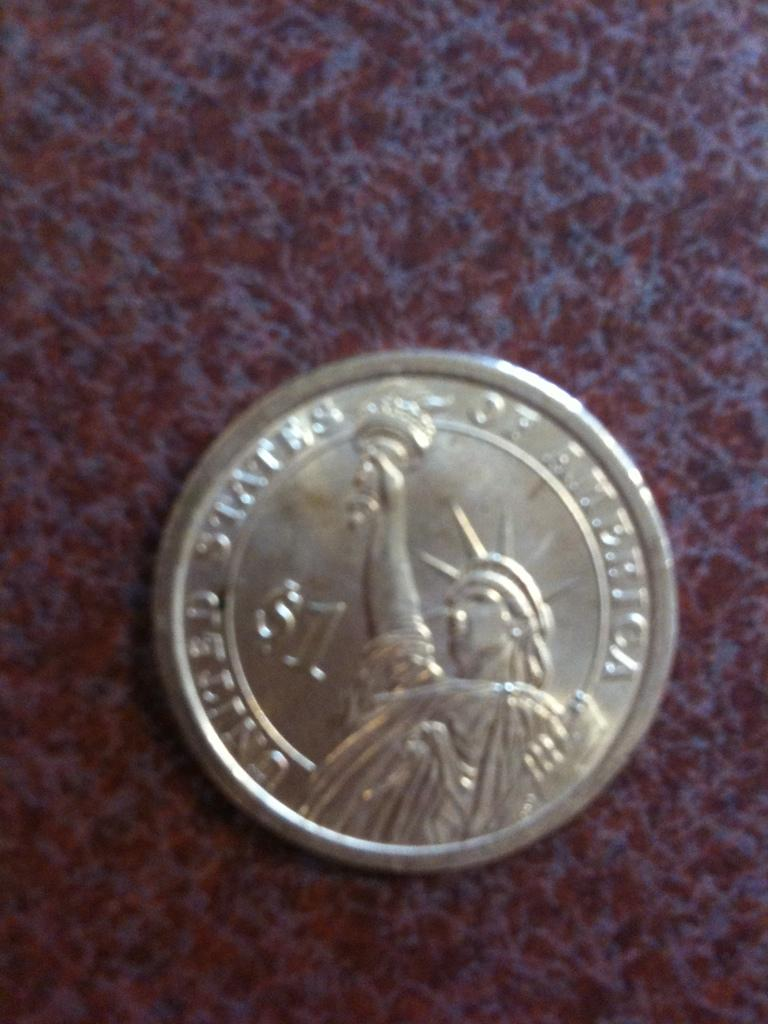<image>
Write a terse but informative summary of the picture. A dollar coin has the United States of America inscribed on it. 